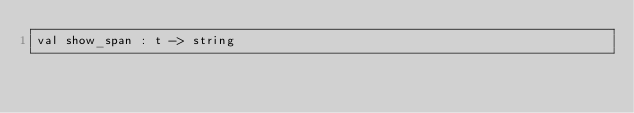Convert code to text. <code><loc_0><loc_0><loc_500><loc_500><_OCaml_>val show_span : t -> string
</code> 